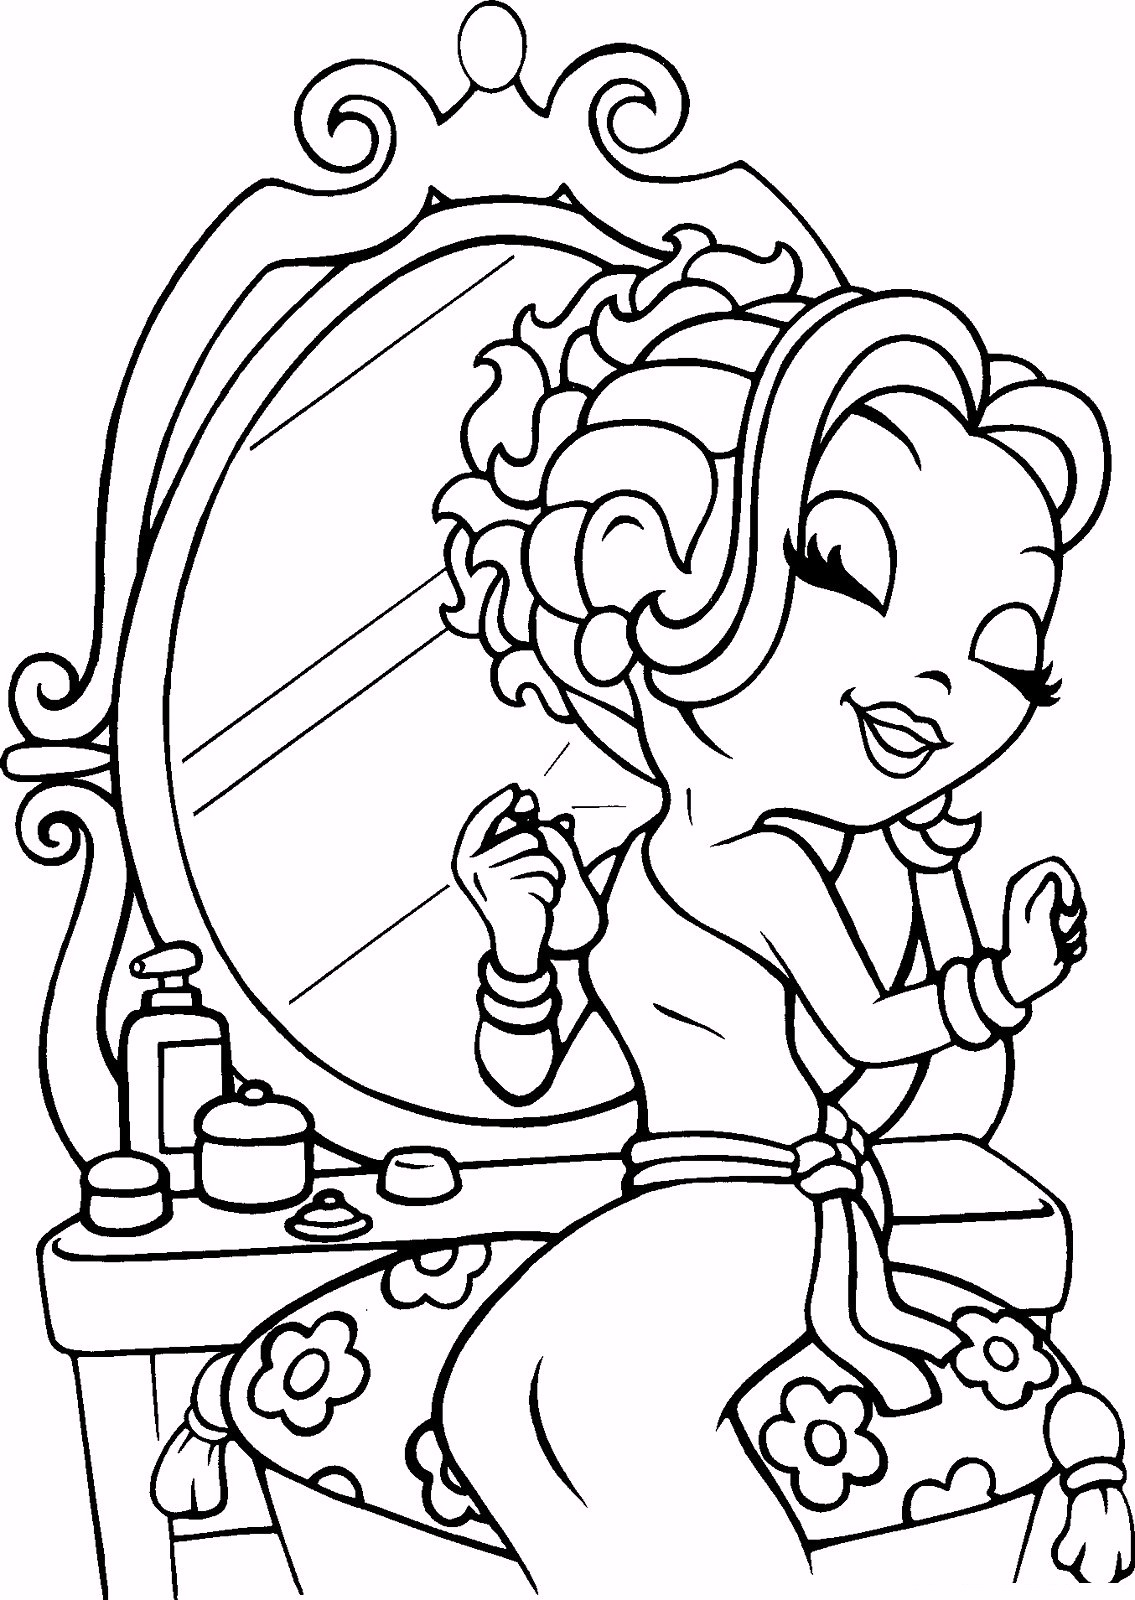Suppose the girl is actually an undercover detective hiding as a makeup artist, getting ready for a mission. How do the items on the table play into her cover and her mission? As an undercover detective posing as a makeup artist, the items on the table play crucial roles in maintaining her cover and aiding in her mission. The cosmetics and nail care products not only solidify her disguise but also conceal essential tools of her trade. The small container with a lid might hide a compact microphone or a device for picking locks. The lotion bottle could contain a special solution for fingerprint analysis. The mirror not only serves for everyday grooming but also provides her with a means to observe her surroundings discreetly. Each item is carefully chosen to blend in with her cover as a makeup artist while equipping her with everything she needs to carry out her covert operations. What if she had to create a hidden message in the pattern on her nails to communicate with another agent? Describe how she might do it. To create a hidden message in the pattern on her nails, she would use a combination of intricate designs and subtle codes that only the receiving agent would understand. For instance, she might use Morse code, painting tiny dots and dashes as part of an elegant floral design. Each dot or dash could be a different color to help disguise the message within the art. Alternatively, she might use a Steganographic approach where a seemingly random arrangement of colors and symbols actually represented letters or numbers when viewed under a specific light or angle. By cleverly incorporating these elements into her nail design, she could transmit vital information without arousing suspicion, maintaining her cover while ensuring critical messages were delivered to her fellow agent. 